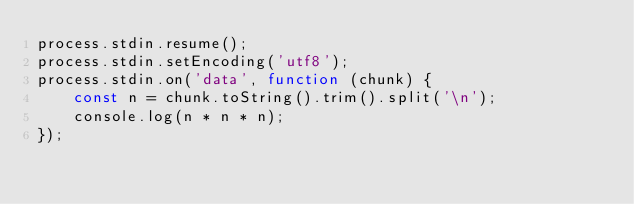Convert code to text. <code><loc_0><loc_0><loc_500><loc_500><_JavaScript_>process.stdin.resume();
process.stdin.setEncoding('utf8');
process.stdin.on('data', function (chunk) {
    const n = chunk.toString().trim().split('\n');
    console.log(n * n * n);
});
</code> 